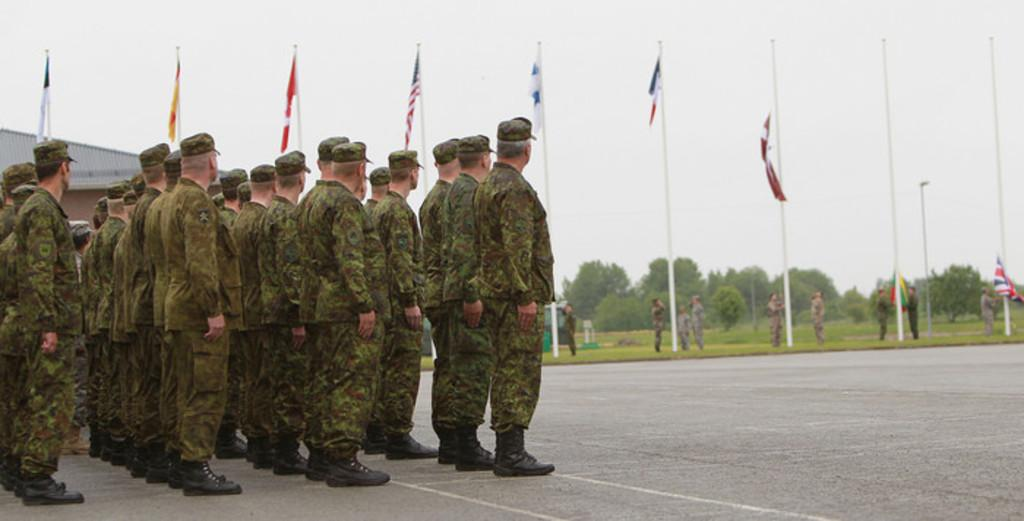What are the people in the image wearing? The people in the image are wearing uniforms. What can be seen in the background of the image? In the background of the image, there are flags, a shade, trees, poles, and the sky. How many elements can be identified in the background of the image? There are six elements in the background of the image: flags, a shade, trees, poles, and the sky. What type of skirt is the bear wearing in the image? There are no bears or skirts present in the image. What activity are the people in the image participating in during recess? The image does not provide information about the people's activity or the concept of recess. 